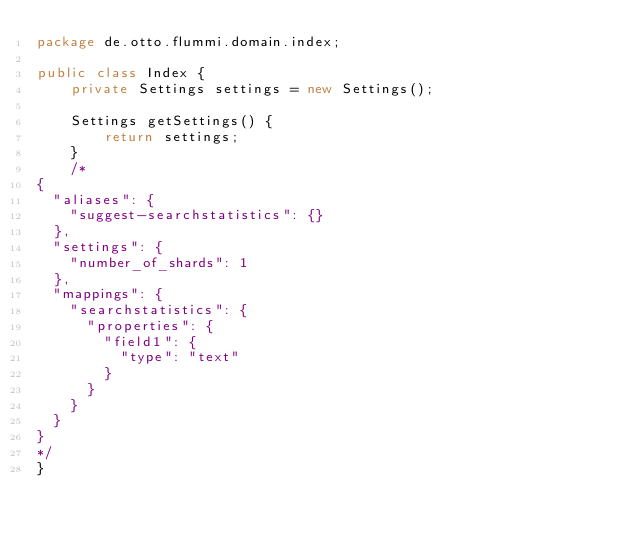Convert code to text. <code><loc_0><loc_0><loc_500><loc_500><_Java_>package de.otto.flummi.domain.index;

public class Index {
    private Settings settings = new Settings();

    Settings getSettings() {
        return settings;
    }
    /*
{
  "aliases": {
    "suggest-searchstatistics": {}
  },
  "settings": {
    "number_of_shards": 1
  },
  "mappings": {
    "searchstatistics": {
      "properties": {
        "field1": {
          "type": "text"
        }
      }
    }
  }
}
*/
}
</code> 